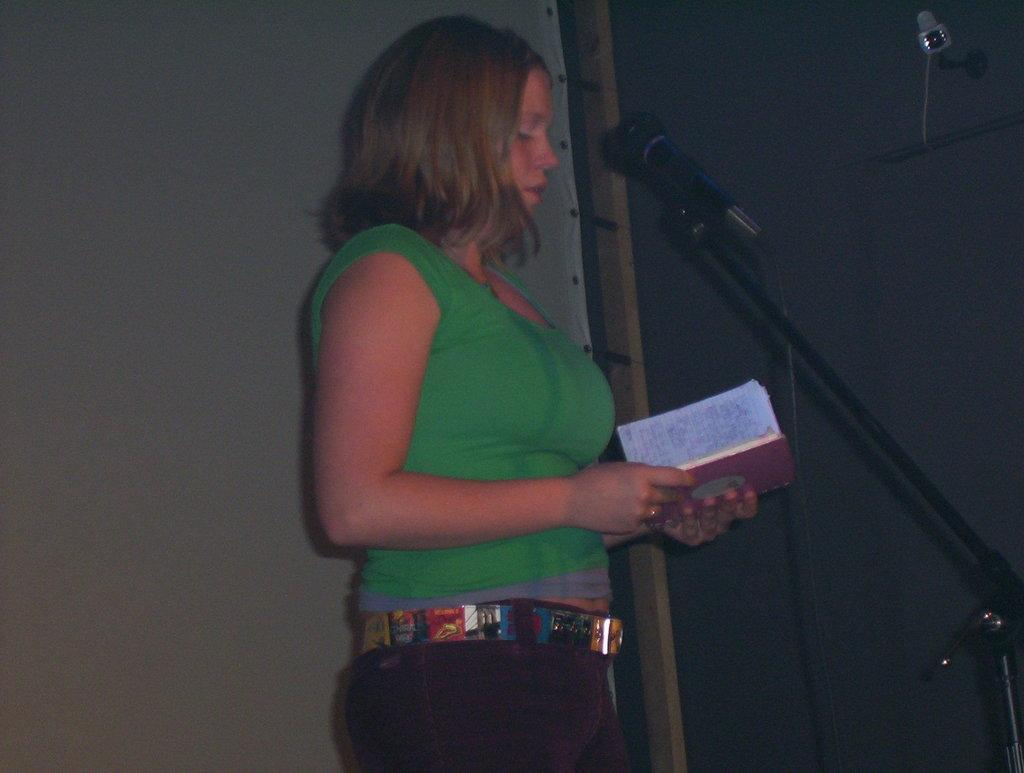Who is the main subject in the image? There is a woman in the center of the image. What is the woman holding in the image? The woman is holding a book. What can be seen on the right side of the image? There is a microphone on the right side of the image. What device is used for capturing images in the image? There is a camera in the image. What object is located on the left side of the image? There is an object on the left side of the image. What type of salt is being used in the image? There is no salt present in the image. How many weeks are depicted in the image? There is no reference to time or weeks in the image. 